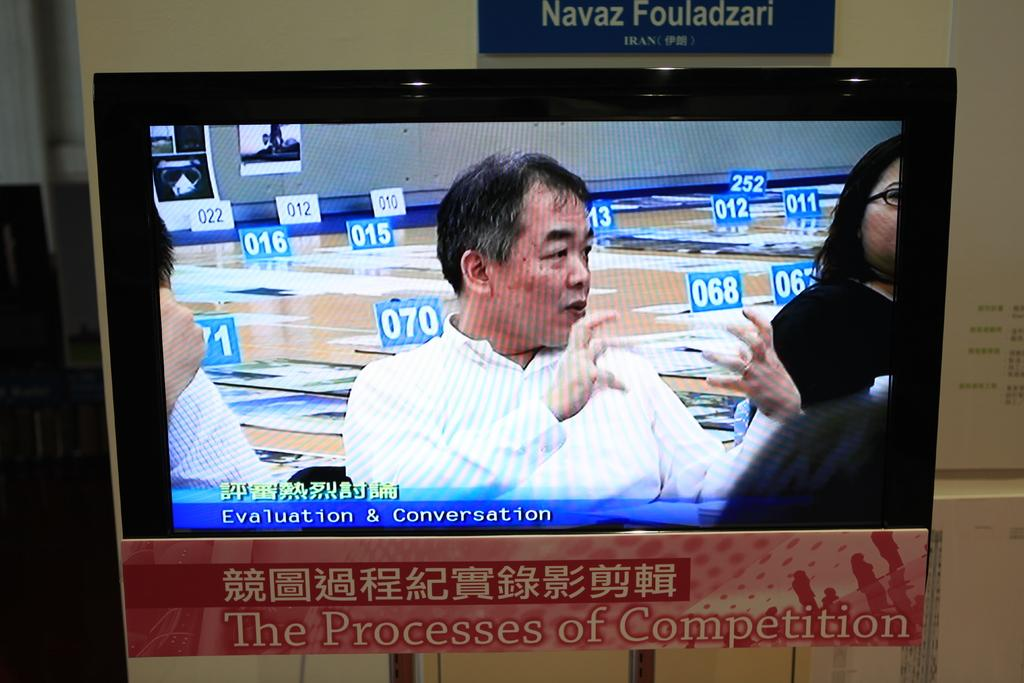<image>
Write a terse but informative summary of the picture. The Asian man is on the screen holding his hands out in a grabbing motion and underneath him it says Evaluation & Conversation. 